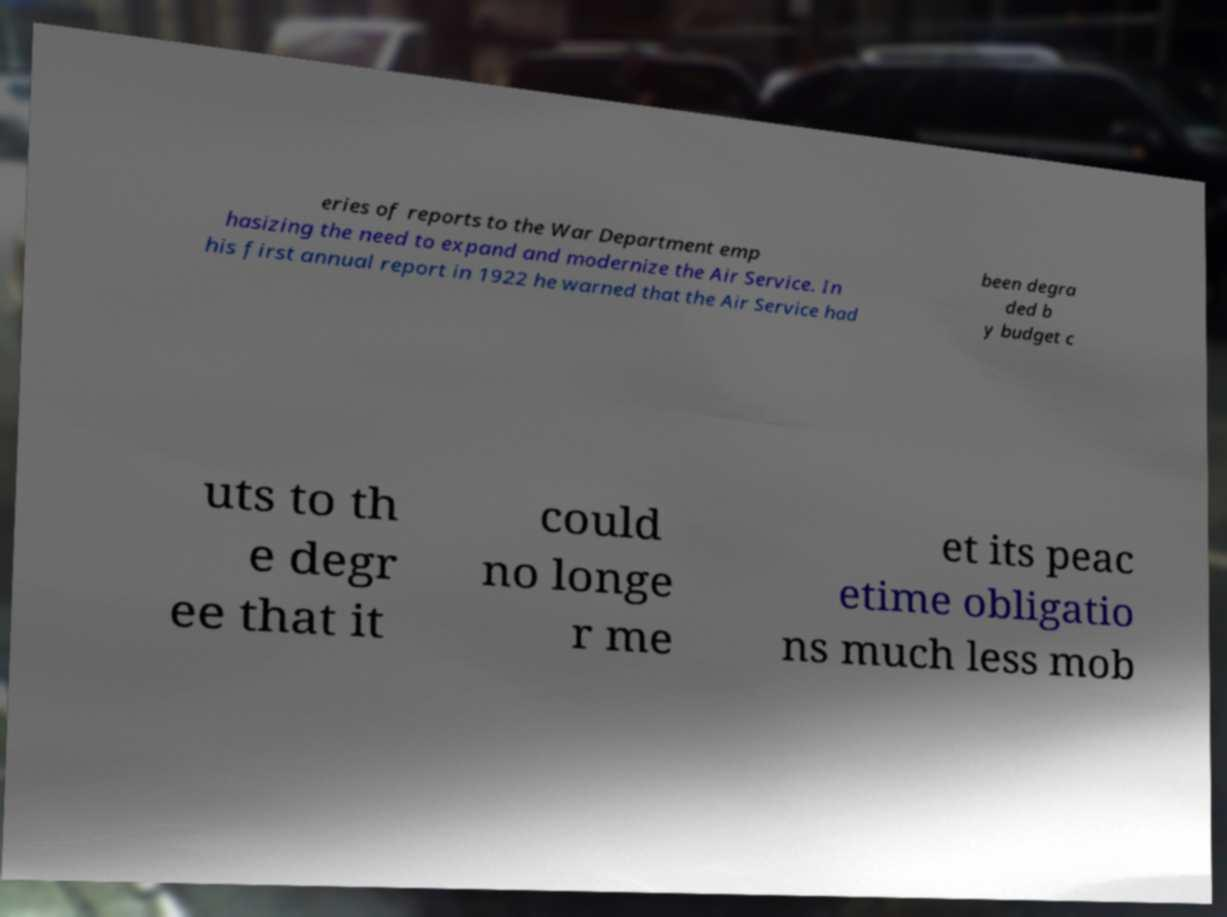Please identify and transcribe the text found in this image. eries of reports to the War Department emp hasizing the need to expand and modernize the Air Service. In his first annual report in 1922 he warned that the Air Service had been degra ded b y budget c uts to th e degr ee that it could no longe r me et its peac etime obligatio ns much less mob 